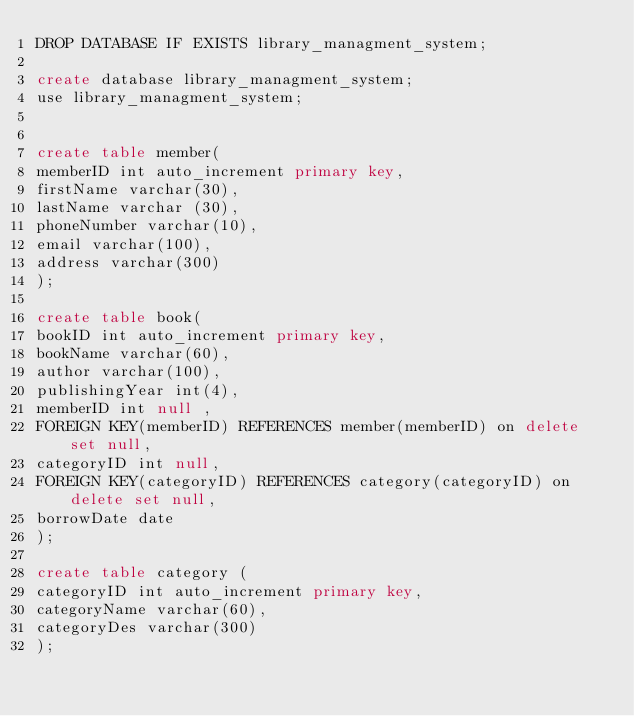<code> <loc_0><loc_0><loc_500><loc_500><_SQL_>DROP DATABASE IF EXISTS library_managment_system;

create database library_managment_system;
use library_managment_system;


create table member(
memberID int auto_increment primary key,
firstName varchar(30),
lastName varchar (30),
phoneNumber varchar(10),
email varchar(100),
address varchar(300)
);

create table book(
bookID int auto_increment primary key,
bookName varchar(60),
author varchar(100),
publishingYear int(4),
memberID int null ,
FOREIGN KEY(memberID) REFERENCES member(memberID) on delete set null,
categoryID int null,
FOREIGN KEY(categoryID) REFERENCES category(categoryID) on delete set null,
borrowDate date
);

create table category (
categoryID int auto_increment primary key,
categoryName varchar(60),
categoryDes varchar(300)
);




</code> 